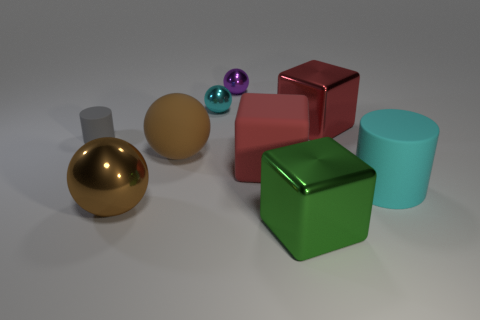Subtract all cyan spheres. How many spheres are left? 3 Subtract all purple balls. How many red cubes are left? 2 Add 1 gray things. How many objects exist? 10 Subtract 2 balls. How many balls are left? 2 Subtract all purple spheres. How many spheres are left? 3 Subtract all cylinders. How many objects are left? 7 Subtract all large purple matte blocks. Subtract all big red metallic objects. How many objects are left? 8 Add 1 tiny gray cylinders. How many tiny gray cylinders are left? 2 Add 5 large cyan matte things. How many large cyan matte things exist? 6 Subtract 0 yellow spheres. How many objects are left? 9 